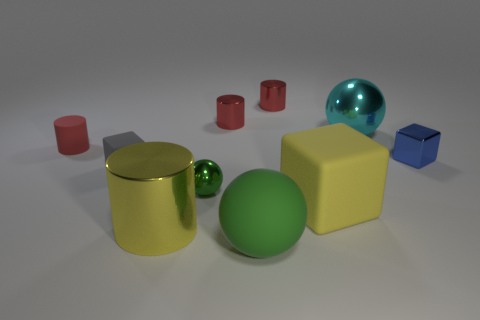Subtract all yellow spheres. How many red cylinders are left? 3 Subtract all cylinders. How many objects are left? 6 Add 2 green objects. How many green objects are left? 4 Add 3 large brown metallic cubes. How many large brown metallic cubes exist? 3 Subtract 2 green spheres. How many objects are left? 8 Subtract all shiny things. Subtract all rubber spheres. How many objects are left? 3 